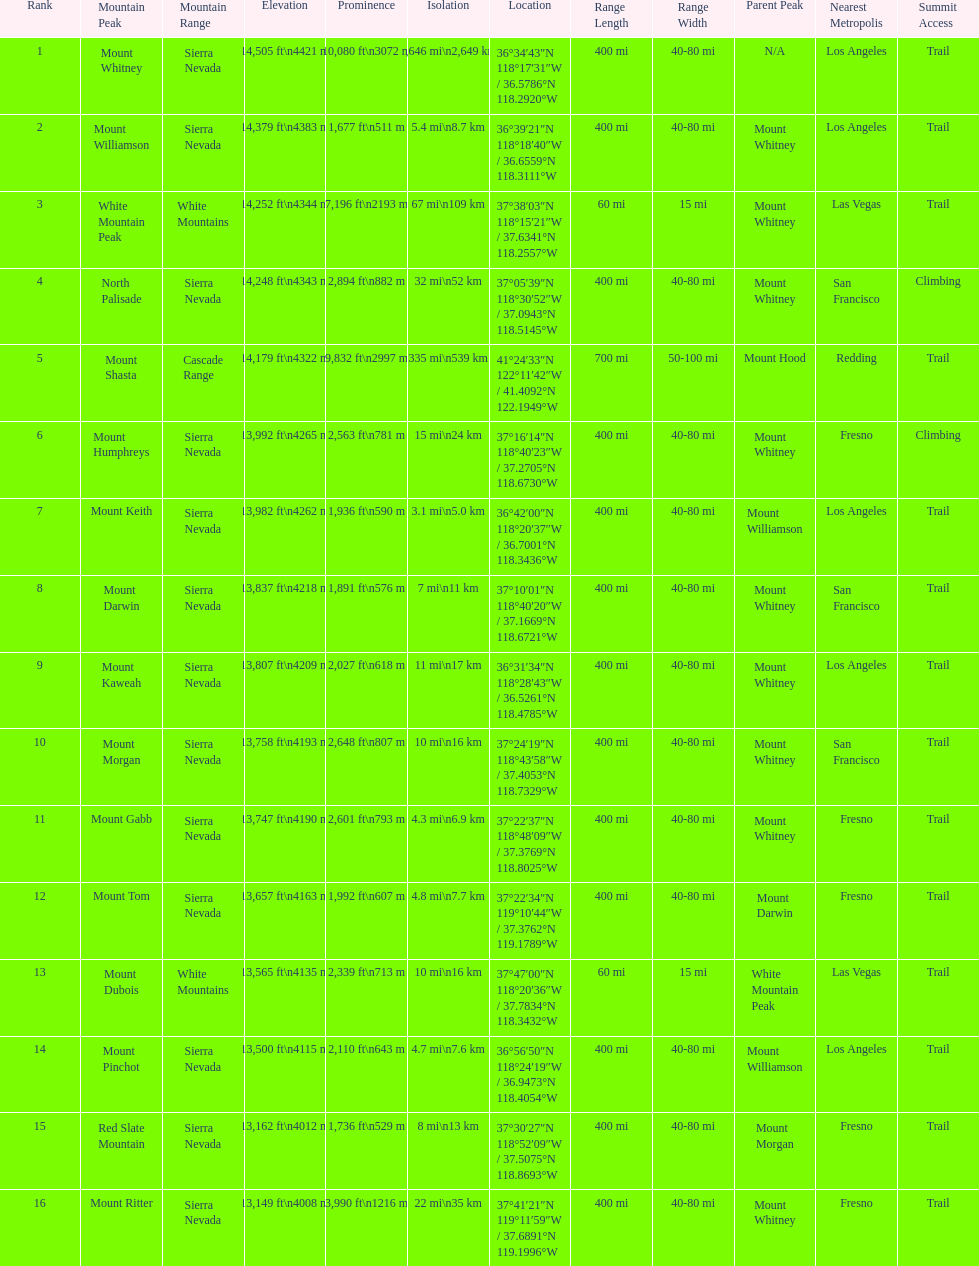What is the only mountain peak listed for the cascade range? Mount Shasta. 